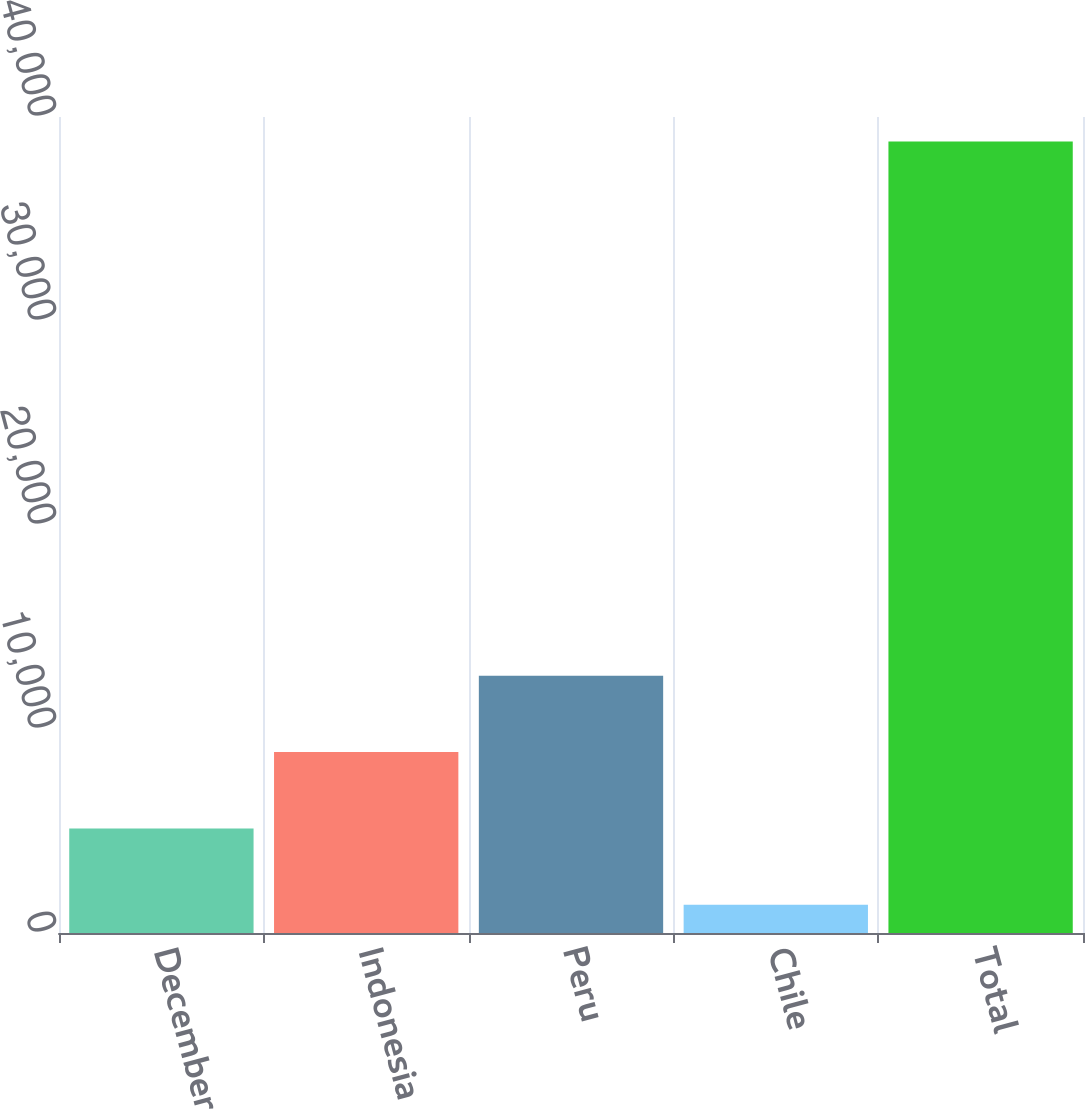Convert chart. <chart><loc_0><loc_0><loc_500><loc_500><bar_chart><fcel>December 31<fcel>Indonesia<fcel>Peru<fcel>Chile<fcel>Total<nl><fcel>5127.8<fcel>8868.6<fcel>12609.4<fcel>1387<fcel>38795<nl></chart> 